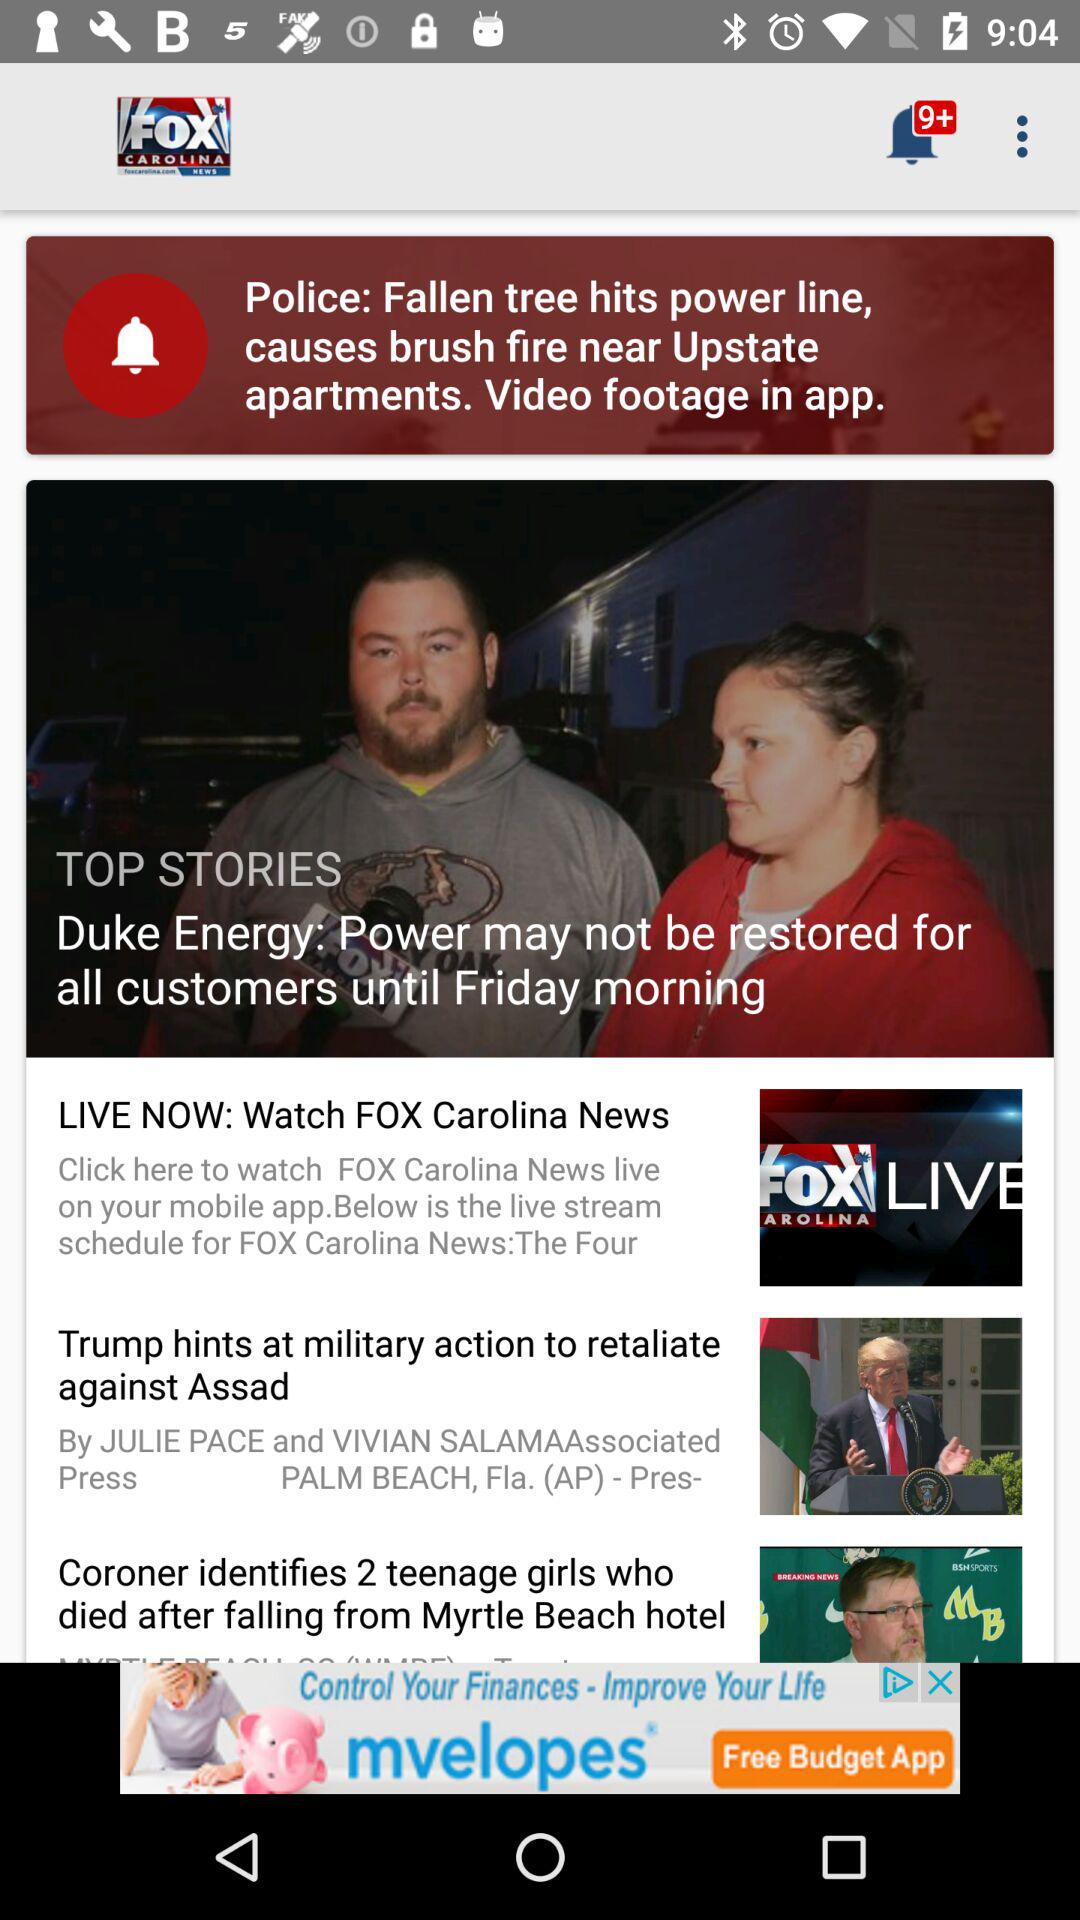What is the name of the application? The name of the application is "FOX CAROLINA NEWS". 